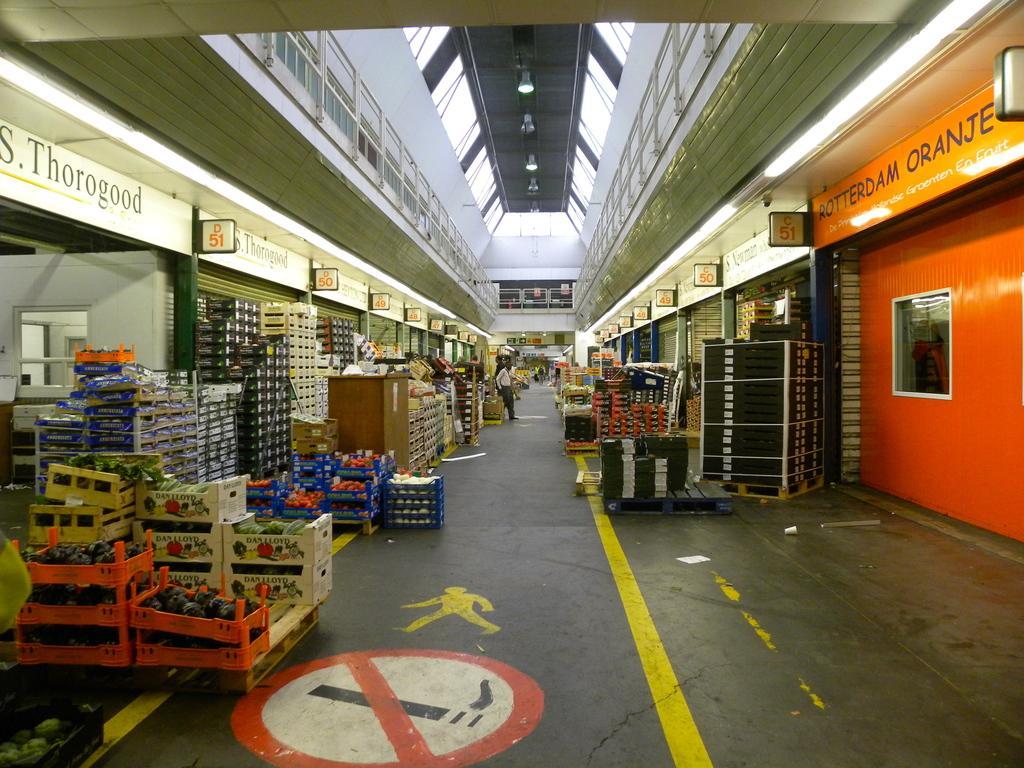Can you describe this image briefly? On the floor on the left and right side we can see carton boxes with food items packed in it and some other items packed in boxes. In the background there are few persons standing on the floor,lights on the roof top,poles,fence,small boards attached to the wall,hoardings and on the roof there is a no smoking sign. 